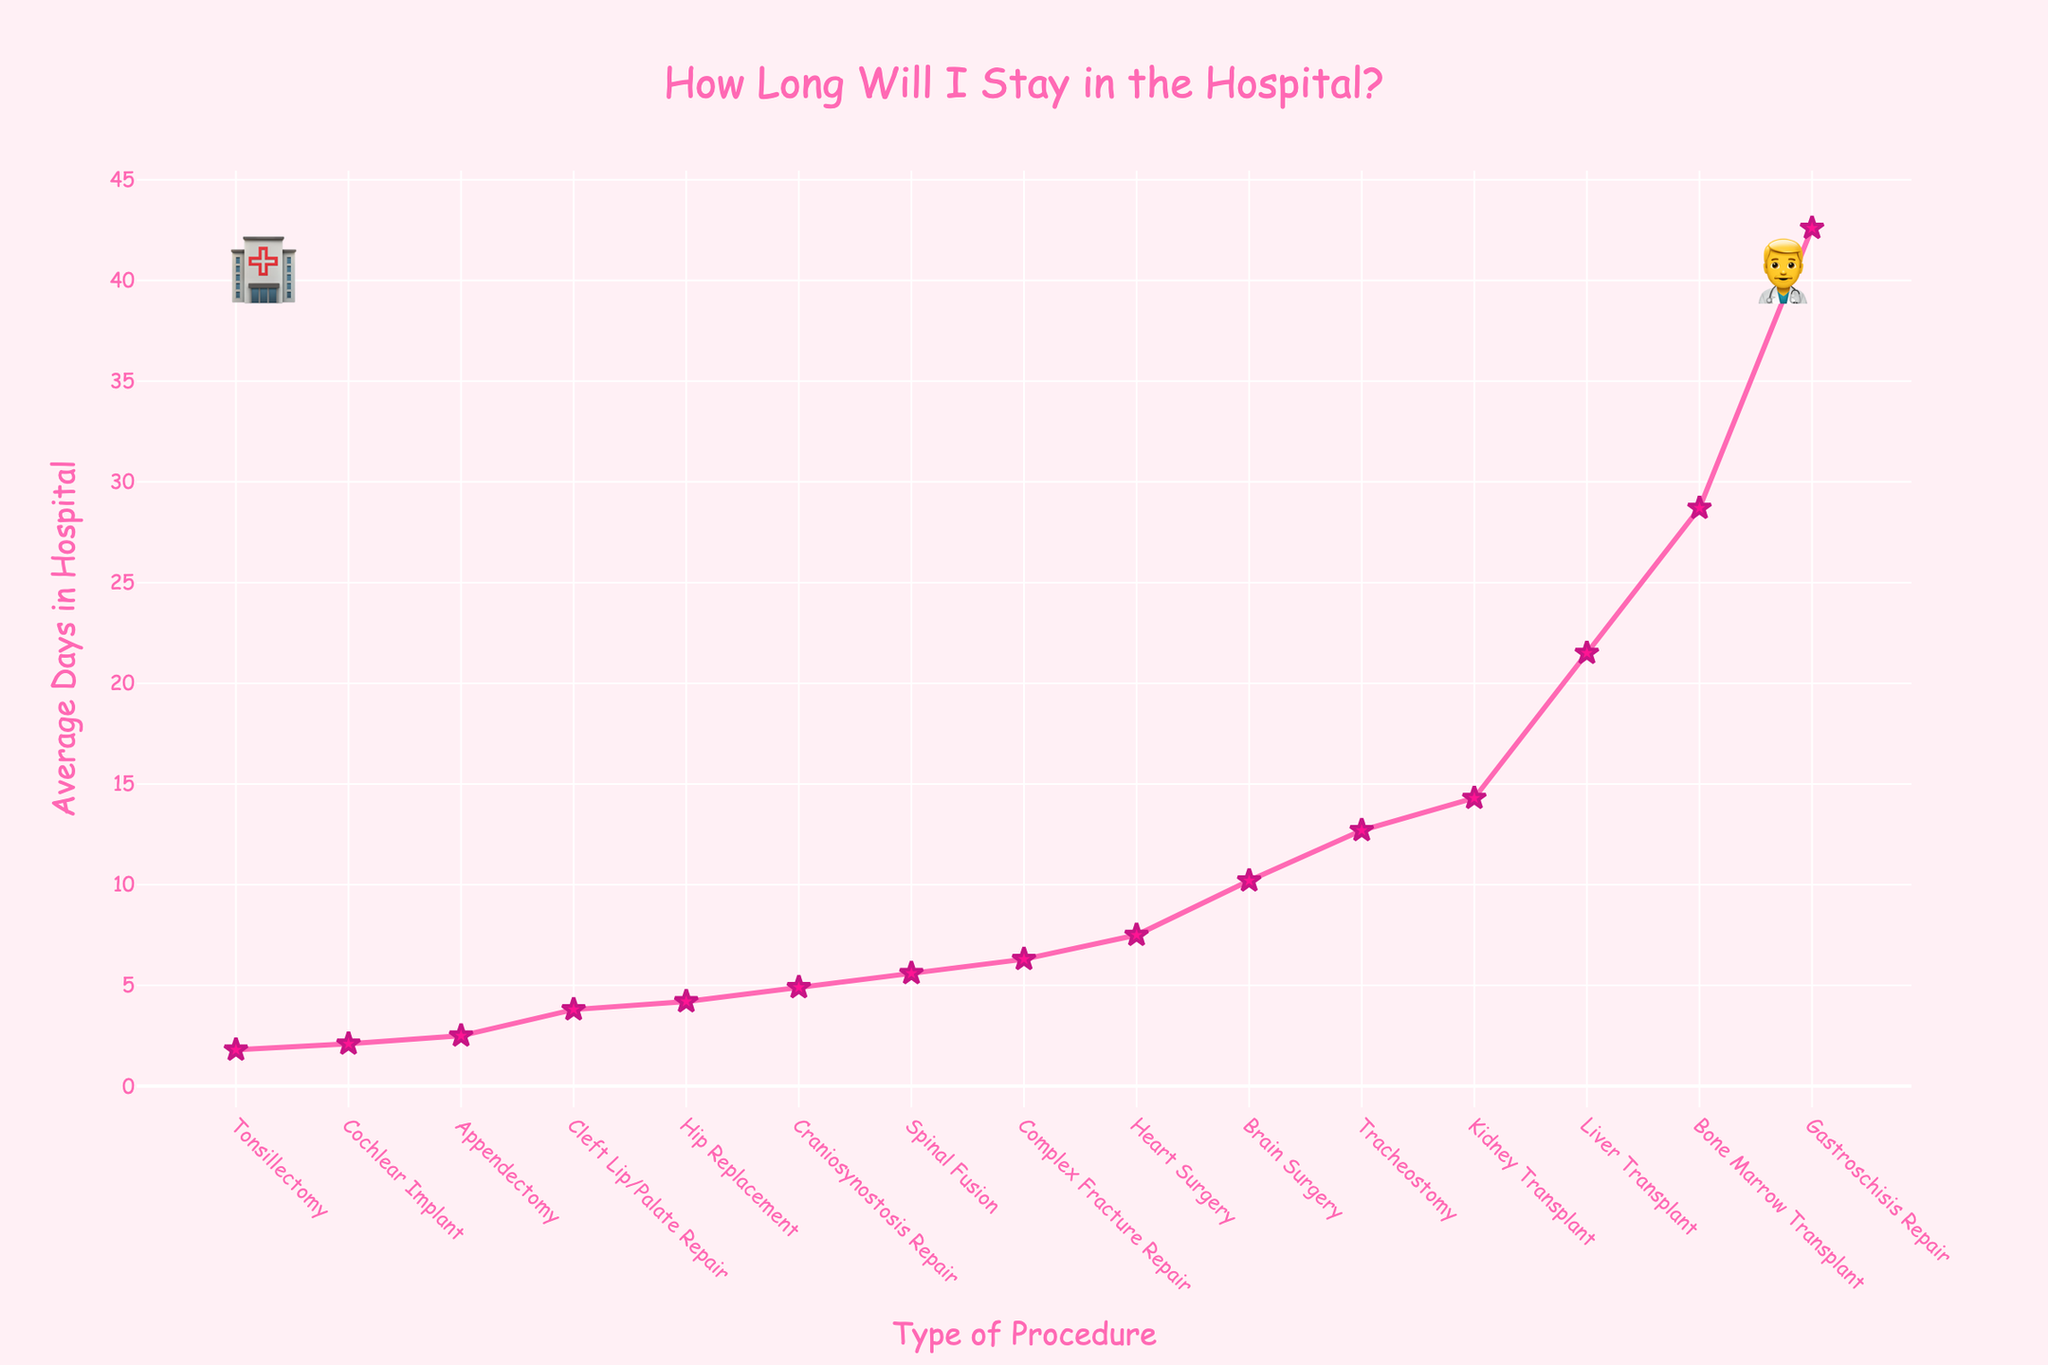Which procedure has the shortest average length of stay? To find the shortest average length of stay, look for the lowest point on the line. The lowest y-value on the chart corresponds to 'Tonsillectomy'.
Answer: Tonsillectomy Which procedure has the longest average length of stay? To find the longest average length of stay, look for the highest point on the line. The highest y-value on the chart corresponds to 'Gastroschisis Repair'.
Answer: Gastroschisis Repair How many days longer is the average stay for a liver transplant compared to a cochlear implant? Identify the y-values for 'Liver Transplant' and 'Cochlear Implant', which are 21.5 days and 2.1 days respectively. Subtract the smaller value from the larger one: 21.5 - 2.1 = 19.4.
Answer: 19.4 Which two procedures have an average length of stay closest to each other? Compare all the y-values to find the pair with the smallest difference. 'Tonsillectomy' (1.8 days) and 'Cochlear Implant' (2.1 days) are the closest, with a difference of 0.3 days.
Answer: Tonsillectomy and Cochlear Implant What is the difference in average length of stay between brain surgery and hip replacement? Find the y-values for 'Brain Surgery' and 'Hip Replacement', which are 10.2 days and 4.2 days respectively. Subtract the smaller value from the larger one: 10.2 - 4.2 = 6.
Answer: 6 How many procedures have an average length of stay greater than 10 days? Count the procedures with y-values greater than 10. These are 'Brain Surgery', 'Kidney Transplant', 'Bone Marrow Transplant', 'Liver Transplant', 'Tracheostomy', and 'Gastroschisis Repair', accounting for 6 procedures.
Answer: 6 What is the average length of stay for heart surgery and spinal fusion combined? Find the y-values for 'Heart Surgery' and 'Spinal Fusion', which are 7.5 days and 5.6 days respectively. Add them together and divide by 2: (7.5 + 5.6) / 2 = 6.55.
Answer: 6.55 Is the average length of stay for complex fracture repair greater than that for craniosynostosis repair? Compare the y-values for 'Complex Fracture Repair' and 'Craniosynostosis Repair'. 'Complex Fracture Repair' is 6.3 days and 'Craniosynostosis Repair' is 4.9 days, so yes, it is greater.
Answer: Yes Which procedure has an average length of stay closest to 5 days? Look for the y-value closest to 5. 'Spinal Fusion' has an average stay of 5.6 days, which is closest to 5.
Answer: Spinal Fusion 